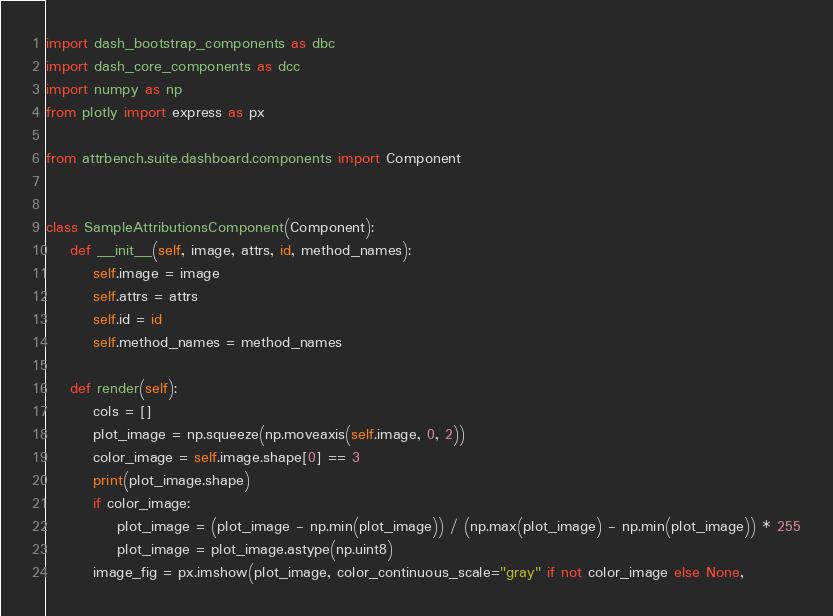<code> <loc_0><loc_0><loc_500><loc_500><_Python_>import dash_bootstrap_components as dbc
import dash_core_components as dcc
import numpy as np
from plotly import express as px

from attrbench.suite.dashboard.components import Component


class SampleAttributionsComponent(Component):
    def __init__(self, image, attrs, id, method_names):
        self.image = image
        self.attrs = attrs
        self.id = id
        self.method_names = method_names

    def render(self):
        cols = []
        plot_image = np.squeeze(np.moveaxis(self.image, 0, 2))
        color_image = self.image.shape[0] == 3
        print(plot_image.shape)
        if color_image:
            plot_image = (plot_image - np.min(plot_image)) / (np.max(plot_image) - np.min(plot_image)) * 255
            plot_image = plot_image.astype(np.uint8)
        image_fig = px.imshow(plot_image, color_continuous_scale="gray" if not color_image else None,</code> 